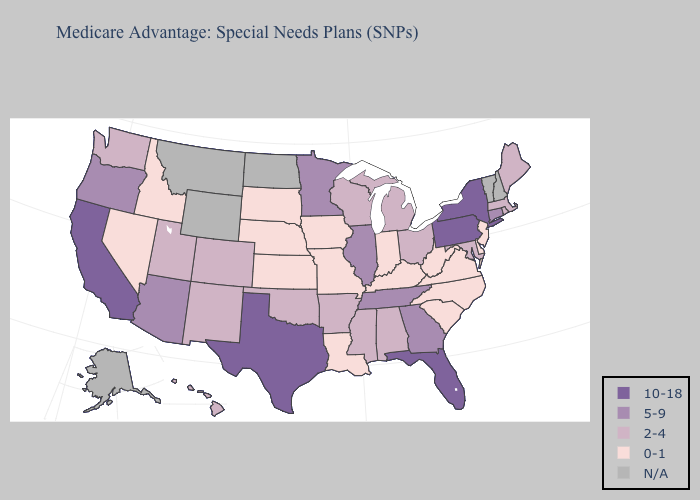What is the highest value in the West ?
Give a very brief answer. 10-18. Does West Virginia have the highest value in the USA?
Be succinct. No. What is the highest value in states that border North Dakota?
Answer briefly. 5-9. Name the states that have a value in the range 10-18?
Concise answer only. California, Florida, New York, Pennsylvania, Texas. Which states have the lowest value in the MidWest?
Give a very brief answer. Iowa, Indiana, Kansas, Missouri, Nebraska, South Dakota. Is the legend a continuous bar?
Write a very short answer. No. What is the value of Washington?
Answer briefly. 2-4. Name the states that have a value in the range N/A?
Concise answer only. Alaska, Montana, North Dakota, New Hampshire, Vermont, Wyoming. Which states hav the highest value in the West?
Be succinct. California. Name the states that have a value in the range 10-18?
Keep it brief. California, Florida, New York, Pennsylvania, Texas. Name the states that have a value in the range 2-4?
Keep it brief. Alabama, Arkansas, Colorado, Hawaii, Massachusetts, Maryland, Maine, Michigan, Mississippi, New Mexico, Ohio, Oklahoma, Rhode Island, Utah, Washington, Wisconsin. What is the value of California?
Be succinct. 10-18. Name the states that have a value in the range 0-1?
Keep it brief. Delaware, Iowa, Idaho, Indiana, Kansas, Kentucky, Louisiana, Missouri, North Carolina, Nebraska, New Jersey, Nevada, South Carolina, South Dakota, Virginia, West Virginia. 